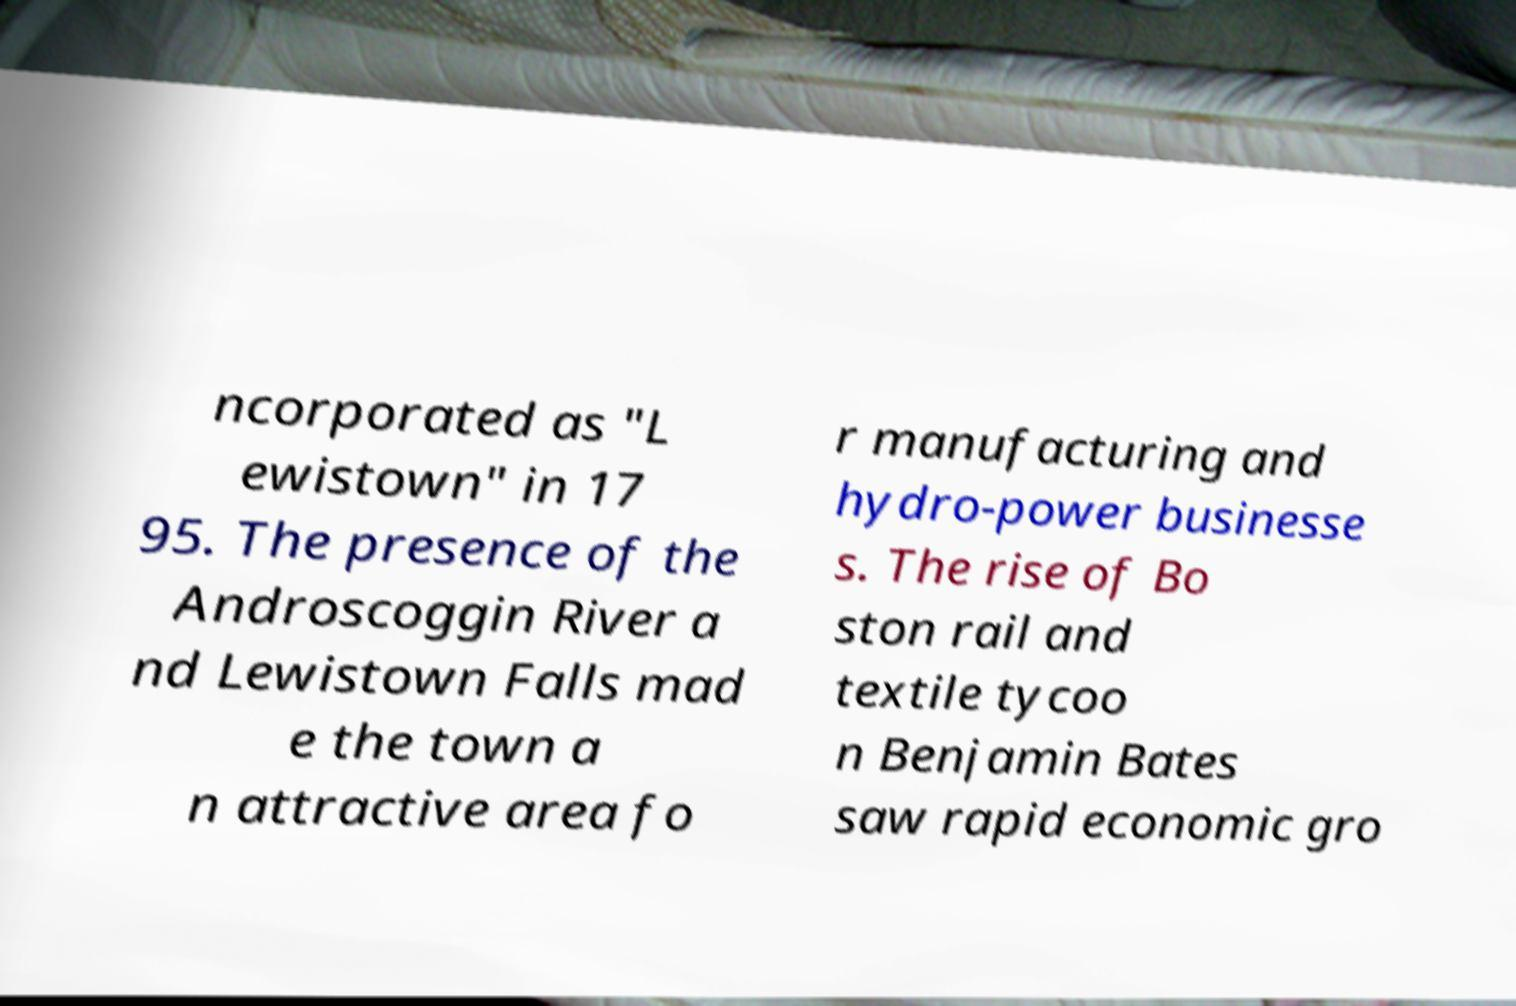Please read and relay the text visible in this image. What does it say? ncorporated as "L ewistown" in 17 95. The presence of the Androscoggin River a nd Lewistown Falls mad e the town a n attractive area fo r manufacturing and hydro-power businesse s. The rise of Bo ston rail and textile tycoo n Benjamin Bates saw rapid economic gro 